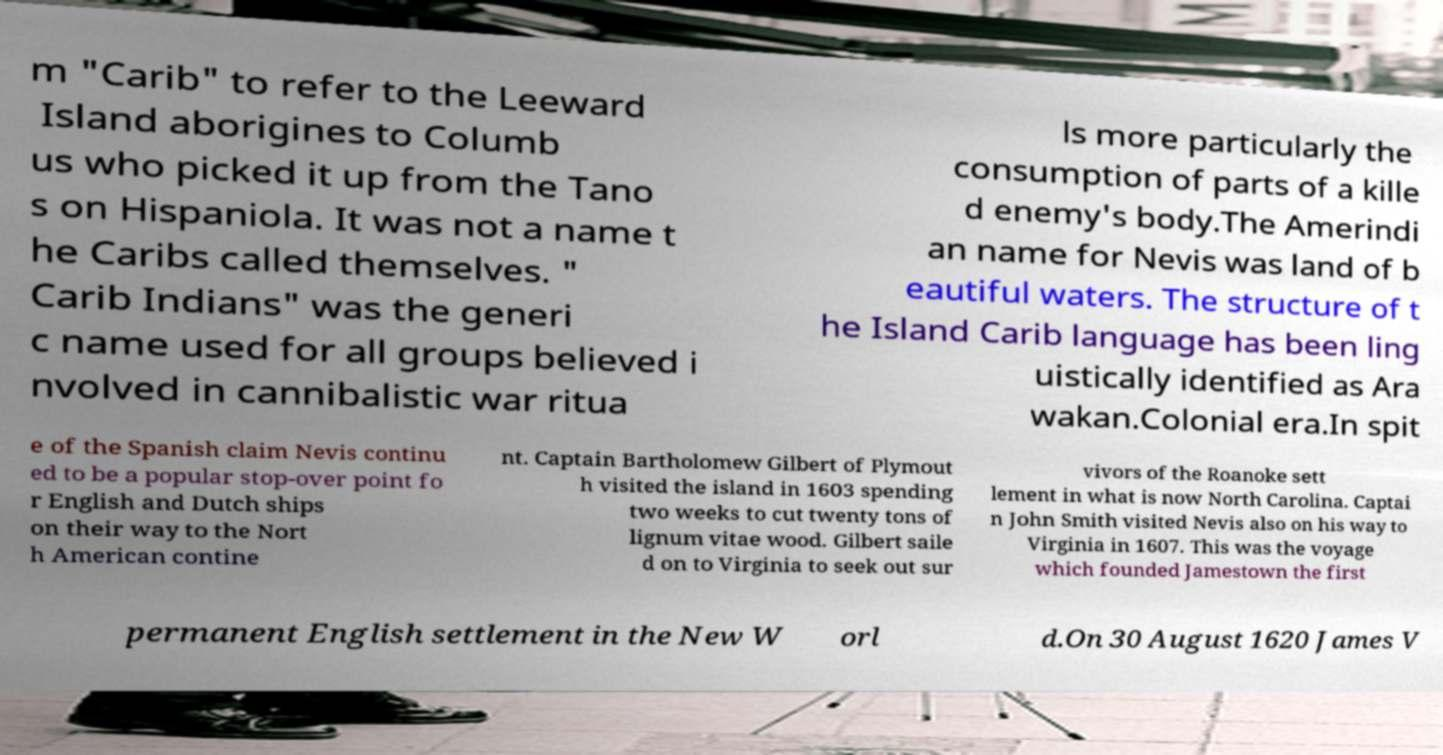What messages or text are displayed in this image? I need them in a readable, typed format. m "Carib" to refer to the Leeward Island aborigines to Columb us who picked it up from the Tano s on Hispaniola. It was not a name t he Caribs called themselves. " Carib Indians" was the generi c name used for all groups believed i nvolved in cannibalistic war ritua ls more particularly the consumption of parts of a kille d enemy's body.The Amerindi an name for Nevis was land of b eautiful waters. The structure of t he Island Carib language has been ling uistically identified as Ara wakan.Colonial era.In spit e of the Spanish claim Nevis continu ed to be a popular stop-over point fo r English and Dutch ships on their way to the Nort h American contine nt. Captain Bartholomew Gilbert of Plymout h visited the island in 1603 spending two weeks to cut twenty tons of lignum vitae wood. Gilbert saile d on to Virginia to seek out sur vivors of the Roanoke sett lement in what is now North Carolina. Captai n John Smith visited Nevis also on his way to Virginia in 1607. This was the voyage which founded Jamestown the first permanent English settlement in the New W orl d.On 30 August 1620 James V 